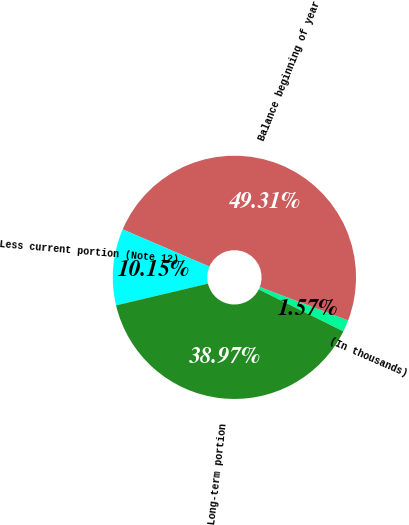Convert chart. <chart><loc_0><loc_0><loc_500><loc_500><pie_chart><fcel>(In thousands)<fcel>Balance beginning of year<fcel>Less current portion (Note 12)<fcel>Long-term portion<nl><fcel>1.57%<fcel>49.31%<fcel>10.15%<fcel>38.97%<nl></chart> 